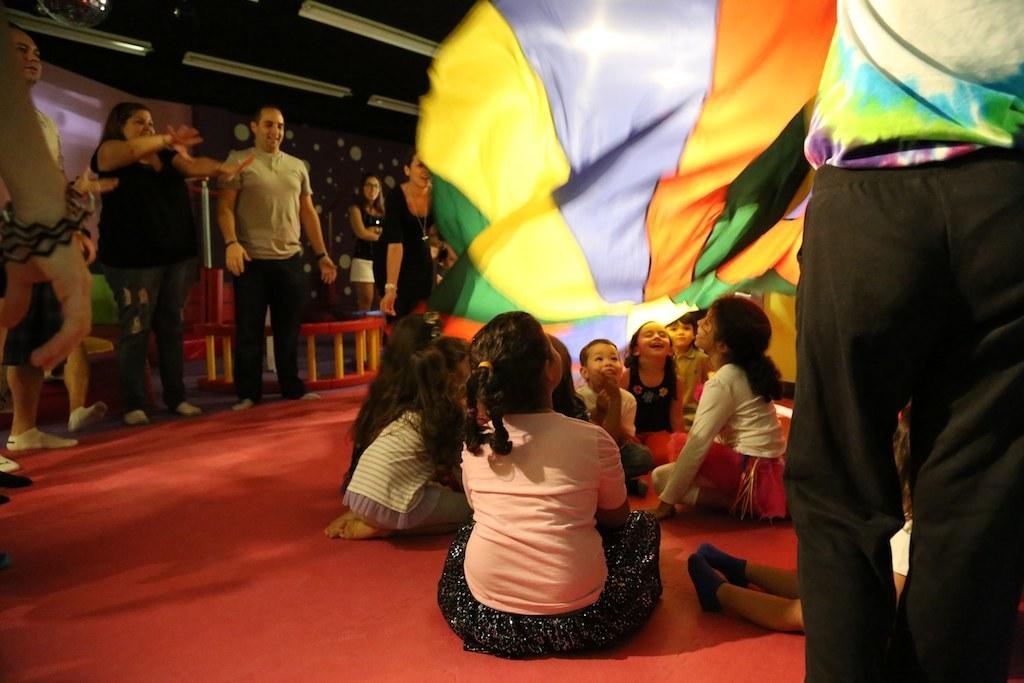Can you describe this image briefly? In this image I can see a group of people are sitting and standing on the floor. In the background I can see a curtain, wall, benches and lights on the rooftop. This image is taken may be in a hall. 